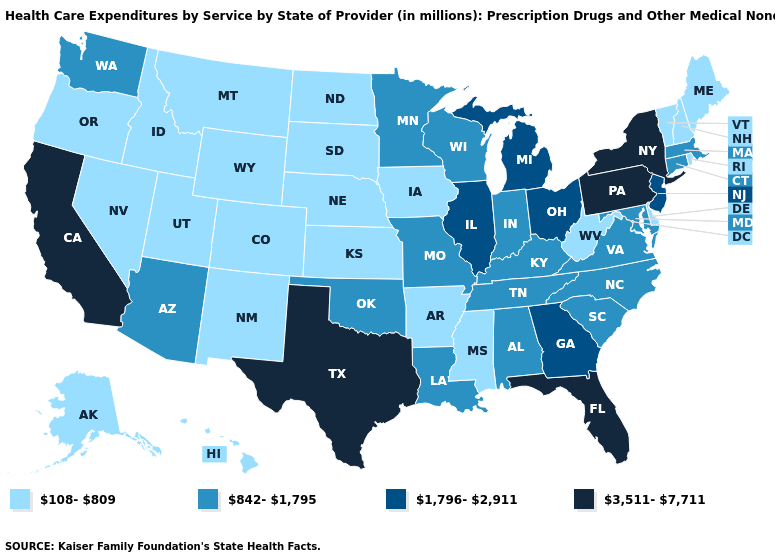Which states hav the highest value in the MidWest?
Concise answer only. Illinois, Michigan, Ohio. What is the lowest value in the South?
Concise answer only. 108-809. Name the states that have a value in the range 842-1,795?
Write a very short answer. Alabama, Arizona, Connecticut, Indiana, Kentucky, Louisiana, Maryland, Massachusetts, Minnesota, Missouri, North Carolina, Oklahoma, South Carolina, Tennessee, Virginia, Washington, Wisconsin. Name the states that have a value in the range 3,511-7,711?
Be succinct. California, Florida, New York, Pennsylvania, Texas. Among the states that border South Carolina , which have the highest value?
Be succinct. Georgia. Name the states that have a value in the range 3,511-7,711?
Quick response, please. California, Florida, New York, Pennsylvania, Texas. Does Nevada have a lower value than Washington?
Concise answer only. Yes. What is the lowest value in states that border Mississippi?
Be succinct. 108-809. Name the states that have a value in the range 1,796-2,911?
Be succinct. Georgia, Illinois, Michigan, New Jersey, Ohio. Name the states that have a value in the range 842-1,795?
Write a very short answer. Alabama, Arizona, Connecticut, Indiana, Kentucky, Louisiana, Maryland, Massachusetts, Minnesota, Missouri, North Carolina, Oklahoma, South Carolina, Tennessee, Virginia, Washington, Wisconsin. Which states hav the highest value in the West?
Be succinct. California. Does Oregon have the highest value in the USA?
Answer briefly. No. Name the states that have a value in the range 1,796-2,911?
Be succinct. Georgia, Illinois, Michigan, New Jersey, Ohio. Among the states that border Iowa , which have the highest value?
Give a very brief answer. Illinois. Among the states that border Kentucky , which have the lowest value?
Write a very short answer. West Virginia. 